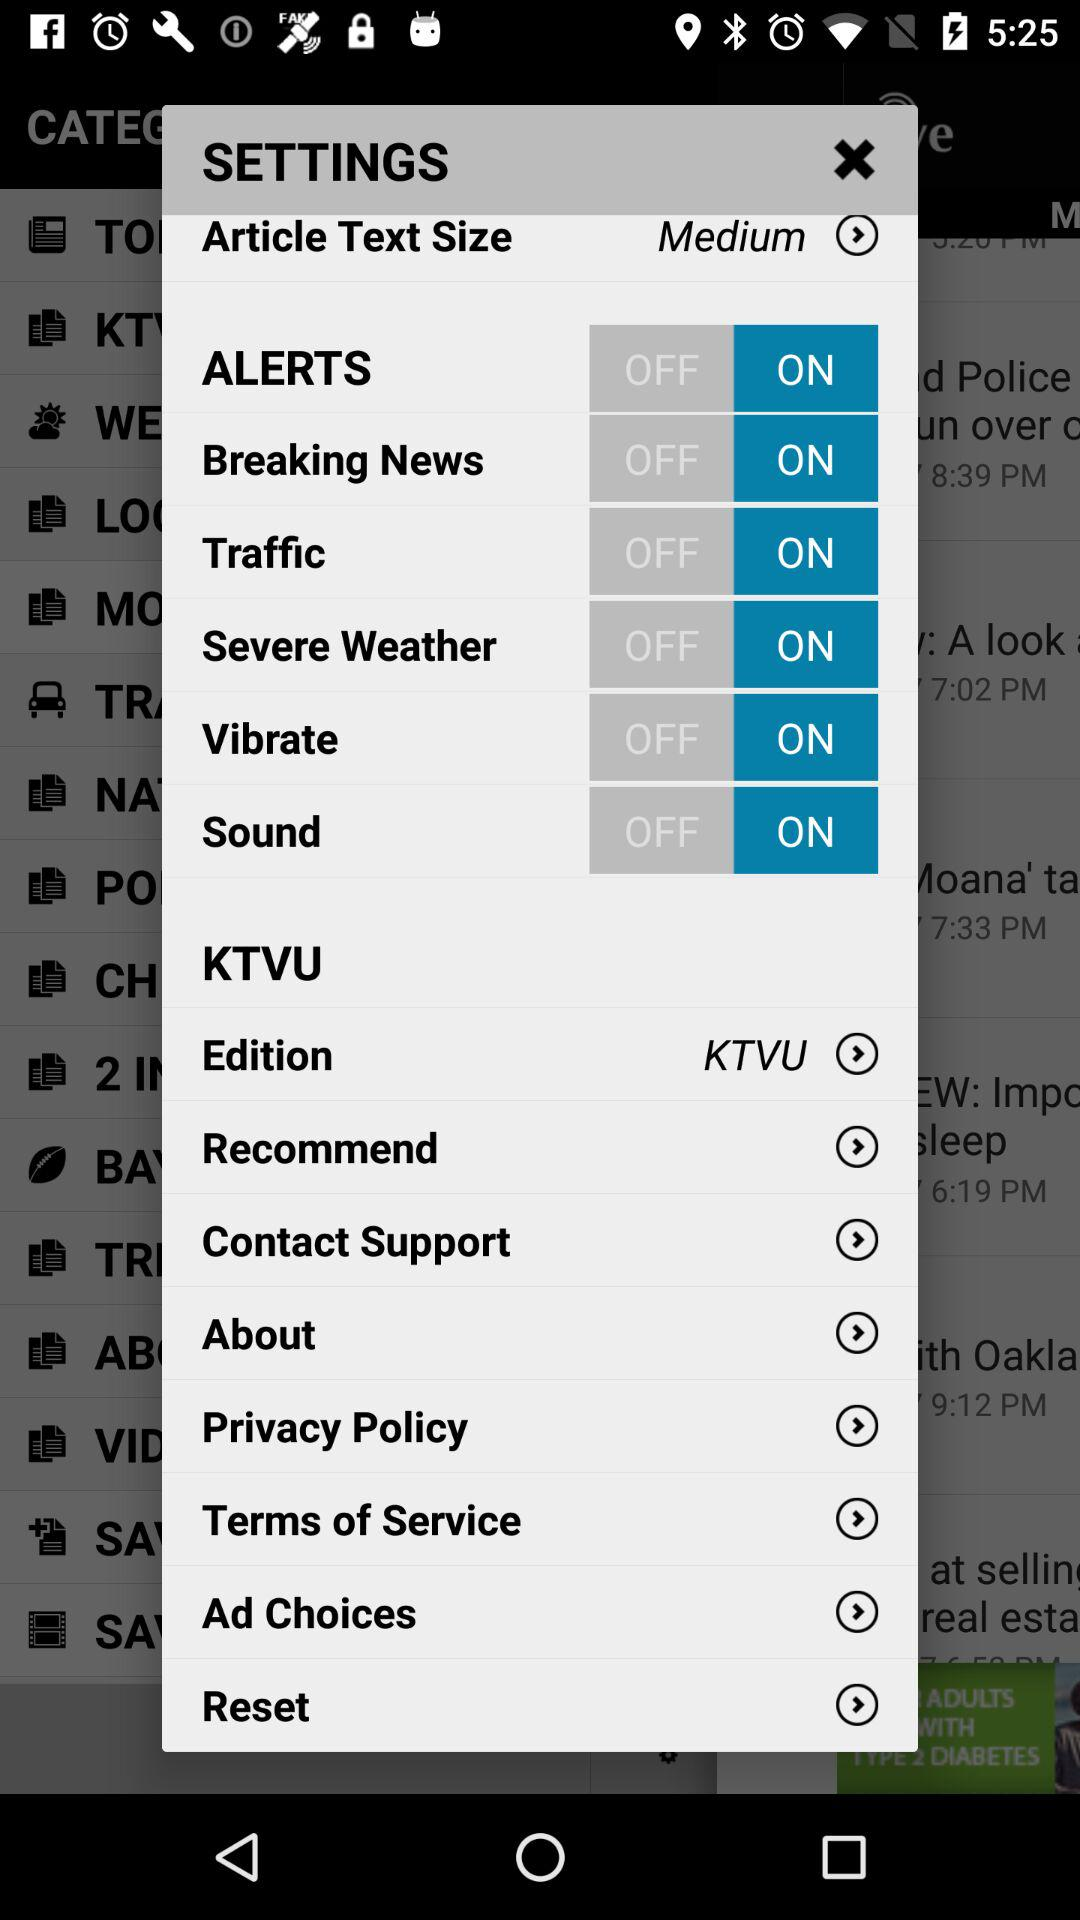What is the selected edition? The selected edition is KTVU. 